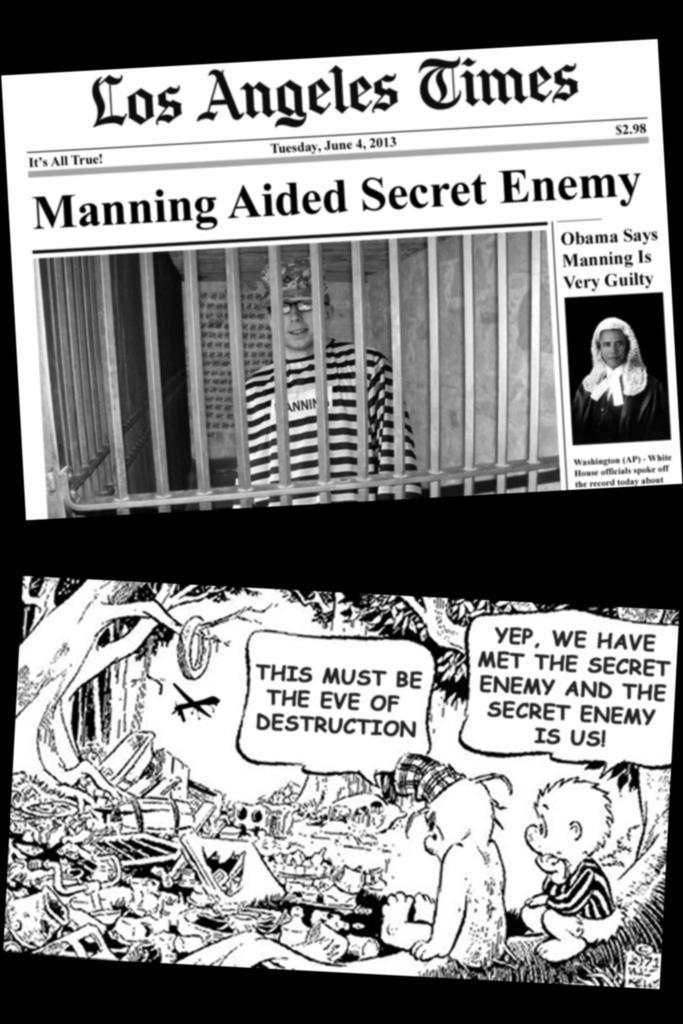In one or two sentences, can you explain what this image depicts? It is an edited image there are two different pictures, in the first image there is a description of some news and in the second picture there are some animated pictures and a conversation between two animals. 